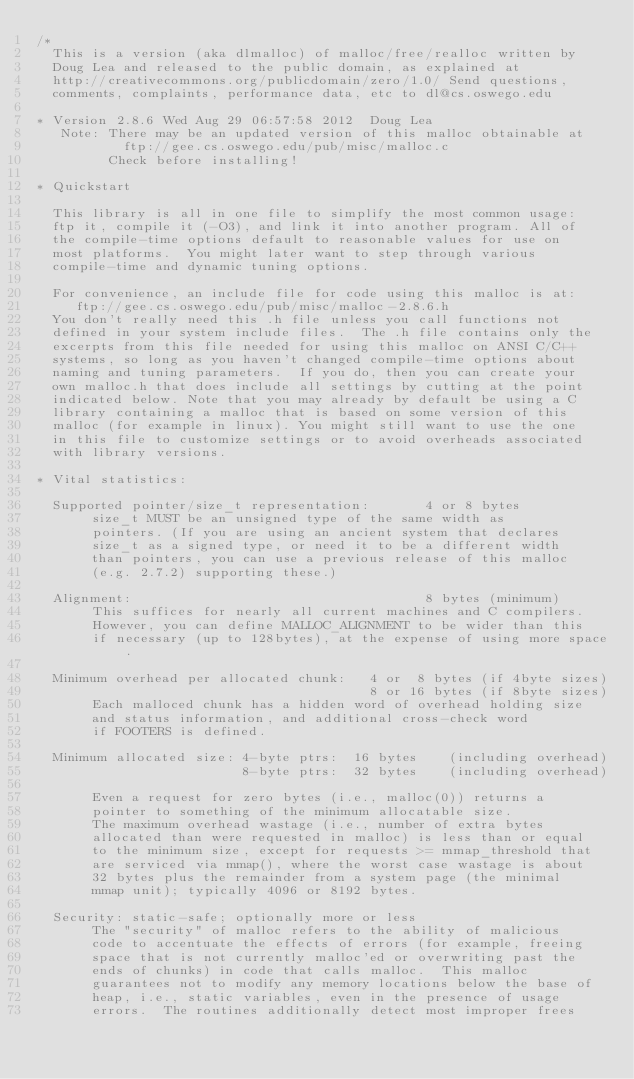<code> <loc_0><loc_0><loc_500><loc_500><_C_>/*
  This is a version (aka dlmalloc) of malloc/free/realloc written by
  Doug Lea and released to the public domain, as explained at
  http://creativecommons.org/publicdomain/zero/1.0/ Send questions,
  comments, complaints, performance data, etc to dl@cs.oswego.edu

* Version 2.8.6 Wed Aug 29 06:57:58 2012  Doug Lea
   Note: There may be an updated version of this malloc obtainable at
           ftp://gee.cs.oswego.edu/pub/misc/malloc.c
         Check before installing!

* Quickstart

  This library is all in one file to simplify the most common usage:
  ftp it, compile it (-O3), and link it into another program. All of
  the compile-time options default to reasonable values for use on
  most platforms.  You might later want to step through various
  compile-time and dynamic tuning options.

  For convenience, an include file for code using this malloc is at:
     ftp://gee.cs.oswego.edu/pub/misc/malloc-2.8.6.h
  You don't really need this .h file unless you call functions not
  defined in your system include files.  The .h file contains only the
  excerpts from this file needed for using this malloc on ANSI C/C++
  systems, so long as you haven't changed compile-time options about
  naming and tuning parameters.  If you do, then you can create your
  own malloc.h that does include all settings by cutting at the point
  indicated below. Note that you may already by default be using a C
  library containing a malloc that is based on some version of this
  malloc (for example in linux). You might still want to use the one
  in this file to customize settings or to avoid overheads associated
  with library versions.

* Vital statistics:

  Supported pointer/size_t representation:       4 or 8 bytes
       size_t MUST be an unsigned type of the same width as
       pointers. (If you are using an ancient system that declares
       size_t as a signed type, or need it to be a different width
       than pointers, you can use a previous release of this malloc
       (e.g. 2.7.2) supporting these.)

  Alignment:                                     8 bytes (minimum)
       This suffices for nearly all current machines and C compilers.
       However, you can define MALLOC_ALIGNMENT to be wider than this
       if necessary (up to 128bytes), at the expense of using more space.

  Minimum overhead per allocated chunk:   4 or  8 bytes (if 4byte sizes)
                                          8 or 16 bytes (if 8byte sizes)
       Each malloced chunk has a hidden word of overhead holding size
       and status information, and additional cross-check word
       if FOOTERS is defined.

  Minimum allocated size: 4-byte ptrs:  16 bytes    (including overhead)
                          8-byte ptrs:  32 bytes    (including overhead)

       Even a request for zero bytes (i.e., malloc(0)) returns a
       pointer to something of the minimum allocatable size.
       The maximum overhead wastage (i.e., number of extra bytes
       allocated than were requested in malloc) is less than or equal
       to the minimum size, except for requests >= mmap_threshold that
       are serviced via mmap(), where the worst case wastage is about
       32 bytes plus the remainder from a system page (the minimal
       mmap unit); typically 4096 or 8192 bytes.

  Security: static-safe; optionally more or less
       The "security" of malloc refers to the ability of malicious
       code to accentuate the effects of errors (for example, freeing
       space that is not currently malloc'ed or overwriting past the
       ends of chunks) in code that calls malloc.  This malloc
       guarantees not to modify any memory locations below the base of
       heap, i.e., static variables, even in the presence of usage
       errors.  The routines additionally detect most improper frees</code> 